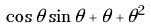<formula> <loc_0><loc_0><loc_500><loc_500>\cos \theta \sin \theta + \theta + \theta ^ { 2 }</formula> 